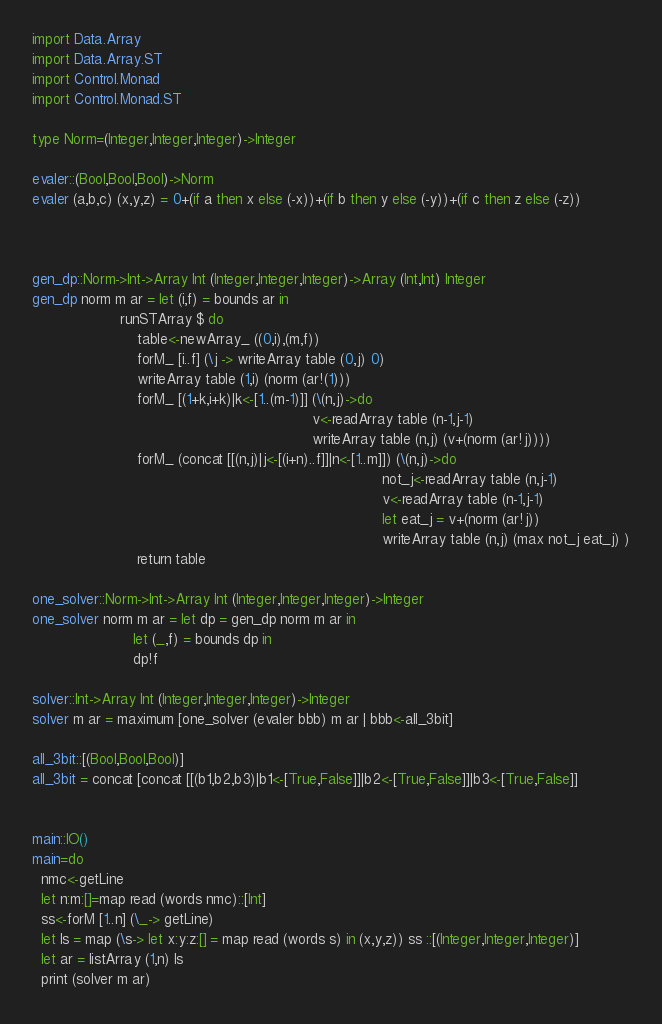<code> <loc_0><loc_0><loc_500><loc_500><_Haskell_>import Data.Array
import Data.Array.ST
import Control.Monad
import Control.Monad.ST

type Norm=(Integer,Integer,Integer)->Integer

evaler::(Bool,Bool,Bool)->Norm
evaler (a,b,c) (x,y,z) = 0+(if a then x else (-x))+(if b then y else (-y))+(if c then z else (-z))



gen_dp::Norm->Int->Array Int (Integer,Integer,Integer)->Array (Int,Int) Integer
gen_dp norm m ar = let (i,f) = bounds ar in
                    runSTArray $ do
                        table<-newArray_ ((0,i),(m,f))
                        forM_ [i..f] (\j -> writeArray table (0,j) 0)
                        writeArray table (1,i) (norm (ar!(1)))
                        forM_ [(1+k,i+k)|k<-[1..(m-1)]] (\(n,j)->do
                                                                v<-readArray table (n-1,j-1)
                                                                writeArray table (n,j) (v+(norm (ar!j))))
                        forM_ (concat [[(n,j)|j<-[(i+n)..f]]|n<-[1..m]]) (\(n,j)->do
                                                                                not_j<-readArray table (n,j-1)
                                                                                v<-readArray table (n-1,j-1)
                                                                                let eat_j = v+(norm (ar!j))
                                                                                writeArray table (n,j) (max not_j eat_j) )
                        return table

one_solver::Norm->Int->Array Int (Integer,Integer,Integer)->Integer
one_solver norm m ar = let dp = gen_dp norm m ar in
                       let (_,f) = bounds dp in
                       dp!f

solver::Int->Array Int (Integer,Integer,Integer)->Integer
solver m ar = maximum [one_solver (evaler bbb) m ar | bbb<-all_3bit]

all_3bit::[(Bool,Bool,Bool)]
all_3bit = concat [concat [[(b1,b2,b3)|b1<-[True,False]]|b2<-[True,False]]|b3<-[True,False]]


main::IO()
main=do
  nmc<-getLine
  let n:m:[]=map read (words nmc)::[Int]
  ss<-forM [1..n] (\_-> getLine)
  let ls = map (\s-> let x:y:z:[] = map read (words s) in (x,y,z)) ss ::[(Integer,Integer,Integer)]
  let ar = listArray (1,n) ls
  print (solver m ar)</code> 